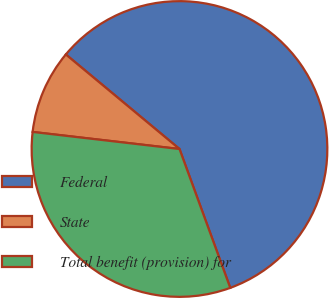Convert chart. <chart><loc_0><loc_0><loc_500><loc_500><pie_chart><fcel>Federal<fcel>State<fcel>Total benefit (provision) for<nl><fcel>58.38%<fcel>9.2%<fcel>32.42%<nl></chart> 